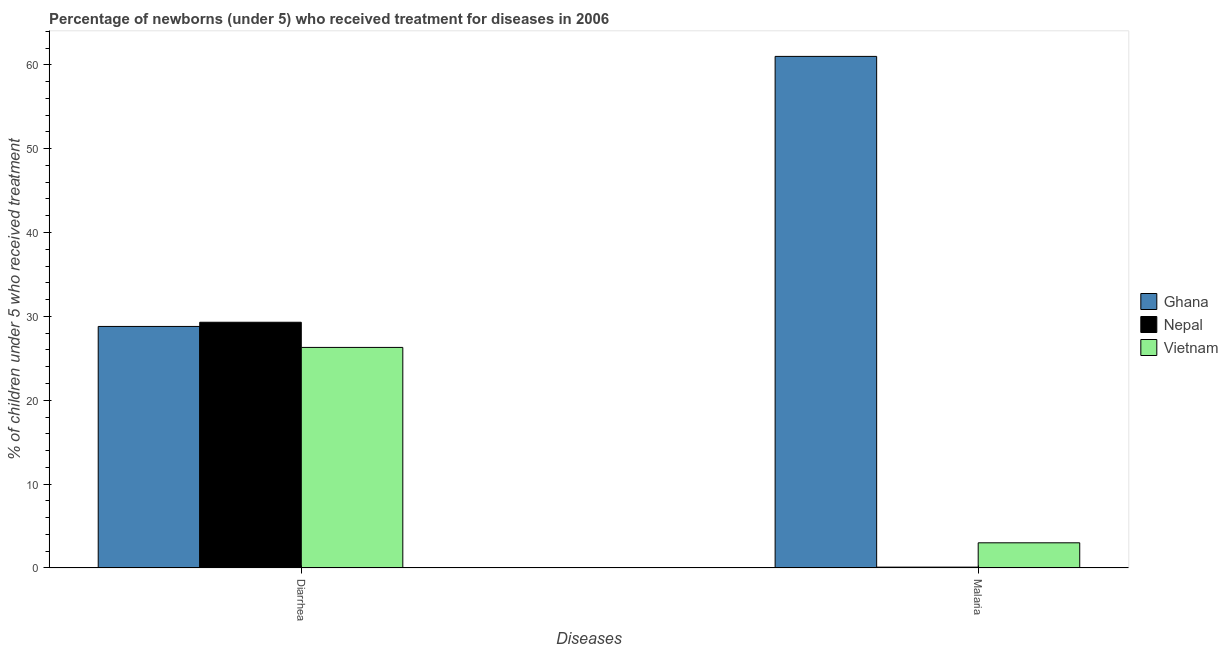Are the number of bars per tick equal to the number of legend labels?
Make the answer very short. Yes. Are the number of bars on each tick of the X-axis equal?
Provide a succinct answer. Yes. How many bars are there on the 2nd tick from the right?
Offer a very short reply. 3. What is the label of the 1st group of bars from the left?
Provide a short and direct response. Diarrhea. Across all countries, what is the maximum percentage of children who received treatment for diarrhoea?
Provide a short and direct response. 29.3. Across all countries, what is the minimum percentage of children who received treatment for malaria?
Provide a short and direct response. 0.1. In which country was the percentage of children who received treatment for diarrhoea maximum?
Provide a short and direct response. Nepal. In which country was the percentage of children who received treatment for diarrhoea minimum?
Make the answer very short. Vietnam. What is the total percentage of children who received treatment for malaria in the graph?
Offer a very short reply. 64.1. What is the difference between the percentage of children who received treatment for malaria in Vietnam and the percentage of children who received treatment for diarrhoea in Ghana?
Provide a succinct answer. -25.8. What is the average percentage of children who received treatment for diarrhoea per country?
Provide a short and direct response. 28.13. What is the difference between the percentage of children who received treatment for diarrhoea and percentage of children who received treatment for malaria in Nepal?
Provide a succinct answer. 29.2. What is the ratio of the percentage of children who received treatment for malaria in Nepal to that in Ghana?
Provide a short and direct response. 0. In how many countries, is the percentage of children who received treatment for malaria greater than the average percentage of children who received treatment for malaria taken over all countries?
Provide a succinct answer. 1. What does the 1st bar from the left in Malaria represents?
Your response must be concise. Ghana. What does the 2nd bar from the right in Diarrhea represents?
Ensure brevity in your answer.  Nepal. Are all the bars in the graph horizontal?
Your answer should be very brief. No. How many countries are there in the graph?
Provide a succinct answer. 3. Does the graph contain any zero values?
Ensure brevity in your answer.  No. Where does the legend appear in the graph?
Keep it short and to the point. Center right. How many legend labels are there?
Offer a terse response. 3. How are the legend labels stacked?
Offer a terse response. Vertical. What is the title of the graph?
Keep it short and to the point. Percentage of newborns (under 5) who received treatment for diseases in 2006. What is the label or title of the X-axis?
Provide a succinct answer. Diseases. What is the label or title of the Y-axis?
Provide a short and direct response. % of children under 5 who received treatment. What is the % of children under 5 who received treatment in Ghana in Diarrhea?
Offer a very short reply. 28.8. What is the % of children under 5 who received treatment in Nepal in Diarrhea?
Offer a terse response. 29.3. What is the % of children under 5 who received treatment of Vietnam in Diarrhea?
Ensure brevity in your answer.  26.3. What is the % of children under 5 who received treatment of Ghana in Malaria?
Give a very brief answer. 61. What is the % of children under 5 who received treatment in Vietnam in Malaria?
Your answer should be compact. 3. Across all Diseases, what is the maximum % of children under 5 who received treatment of Nepal?
Provide a short and direct response. 29.3. Across all Diseases, what is the maximum % of children under 5 who received treatment in Vietnam?
Your answer should be very brief. 26.3. Across all Diseases, what is the minimum % of children under 5 who received treatment in Ghana?
Your answer should be very brief. 28.8. What is the total % of children under 5 who received treatment of Ghana in the graph?
Keep it short and to the point. 89.8. What is the total % of children under 5 who received treatment of Nepal in the graph?
Make the answer very short. 29.4. What is the total % of children under 5 who received treatment in Vietnam in the graph?
Keep it short and to the point. 29.3. What is the difference between the % of children under 5 who received treatment of Ghana in Diarrhea and that in Malaria?
Offer a very short reply. -32.2. What is the difference between the % of children under 5 who received treatment in Nepal in Diarrhea and that in Malaria?
Make the answer very short. 29.2. What is the difference between the % of children under 5 who received treatment of Vietnam in Diarrhea and that in Malaria?
Your response must be concise. 23.3. What is the difference between the % of children under 5 who received treatment in Ghana in Diarrhea and the % of children under 5 who received treatment in Nepal in Malaria?
Give a very brief answer. 28.7. What is the difference between the % of children under 5 who received treatment in Ghana in Diarrhea and the % of children under 5 who received treatment in Vietnam in Malaria?
Keep it short and to the point. 25.8. What is the difference between the % of children under 5 who received treatment in Nepal in Diarrhea and the % of children under 5 who received treatment in Vietnam in Malaria?
Offer a very short reply. 26.3. What is the average % of children under 5 who received treatment in Ghana per Diseases?
Provide a succinct answer. 44.9. What is the average % of children under 5 who received treatment in Vietnam per Diseases?
Offer a terse response. 14.65. What is the difference between the % of children under 5 who received treatment of Ghana and % of children under 5 who received treatment of Nepal in Diarrhea?
Give a very brief answer. -0.5. What is the difference between the % of children under 5 who received treatment of Ghana and % of children under 5 who received treatment of Vietnam in Diarrhea?
Keep it short and to the point. 2.5. What is the difference between the % of children under 5 who received treatment in Ghana and % of children under 5 who received treatment in Nepal in Malaria?
Offer a very short reply. 60.9. What is the difference between the % of children under 5 who received treatment in Nepal and % of children under 5 who received treatment in Vietnam in Malaria?
Keep it short and to the point. -2.9. What is the ratio of the % of children under 5 who received treatment of Ghana in Diarrhea to that in Malaria?
Give a very brief answer. 0.47. What is the ratio of the % of children under 5 who received treatment of Nepal in Diarrhea to that in Malaria?
Keep it short and to the point. 293. What is the ratio of the % of children under 5 who received treatment of Vietnam in Diarrhea to that in Malaria?
Make the answer very short. 8.77. What is the difference between the highest and the second highest % of children under 5 who received treatment of Ghana?
Provide a short and direct response. 32.2. What is the difference between the highest and the second highest % of children under 5 who received treatment in Nepal?
Make the answer very short. 29.2. What is the difference between the highest and the second highest % of children under 5 who received treatment in Vietnam?
Offer a very short reply. 23.3. What is the difference between the highest and the lowest % of children under 5 who received treatment in Ghana?
Provide a short and direct response. 32.2. What is the difference between the highest and the lowest % of children under 5 who received treatment of Nepal?
Offer a very short reply. 29.2. What is the difference between the highest and the lowest % of children under 5 who received treatment in Vietnam?
Your answer should be very brief. 23.3. 